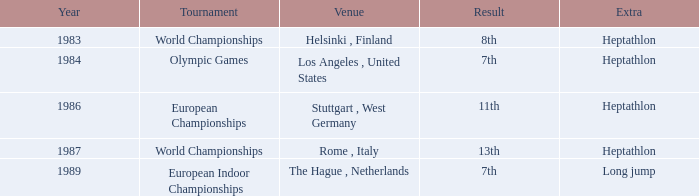What is the frequency of hosting the olympic games? 1984.0. 